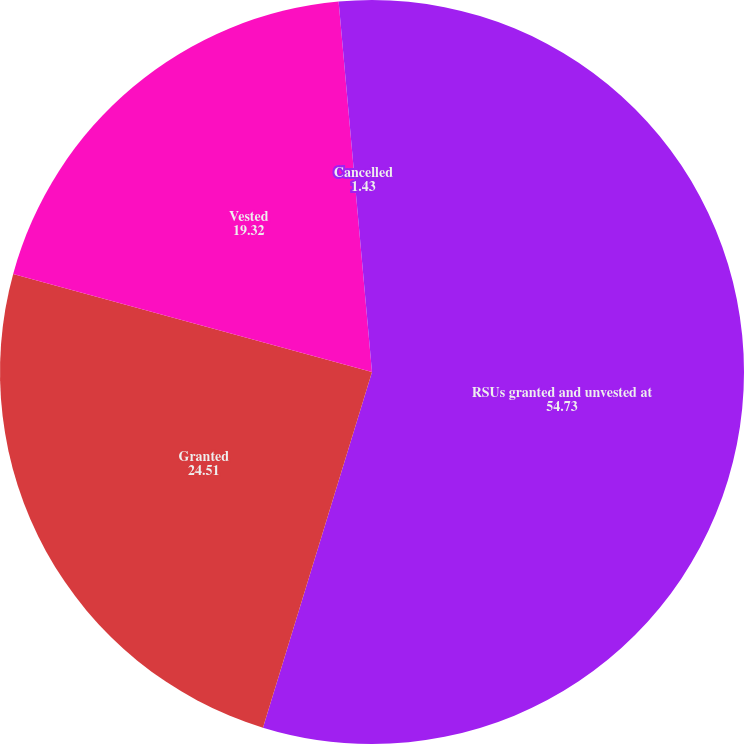<chart> <loc_0><loc_0><loc_500><loc_500><pie_chart><fcel>RSUs granted and unvested at<fcel>Granted<fcel>Vested<fcel>Cancelled<nl><fcel>54.73%<fcel>24.51%<fcel>19.32%<fcel>1.43%<nl></chart> 